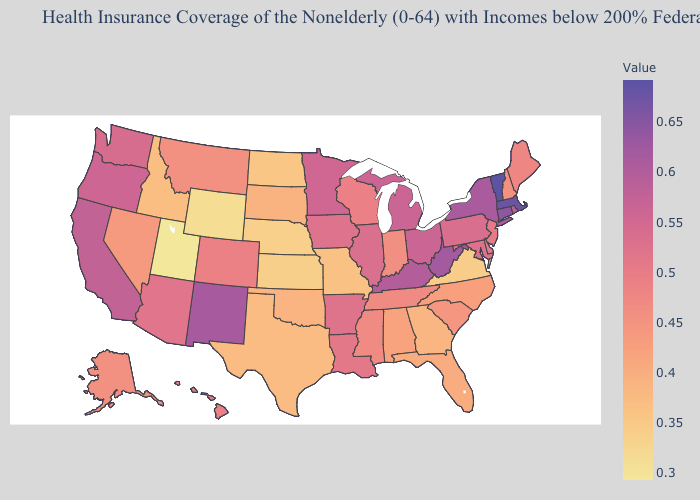Which states have the lowest value in the USA?
Quick response, please. Utah. Which states hav the highest value in the Northeast?
Quick response, please. Vermont. Which states have the highest value in the USA?
Concise answer only. Vermont. Does the map have missing data?
Be succinct. No. 